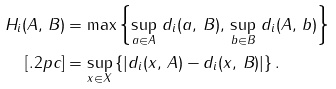Convert formula to latex. <formula><loc_0><loc_0><loc_500><loc_500>H _ { i } ( A , \, B ) & = \max \left \{ \underset { a \in A } { \sup } \ d _ { i } ( a , \, B ) , \, \underset { b \in B } { \sup } \ d _ { i } ( A , \, b ) \right \} \\ [ . 2 p c ] & = \underset { x \in X } { \sup } \left \{ \left | d _ { i } ( x , \, A ) - d _ { i } ( x , \, B ) \right | \right \} .</formula> 